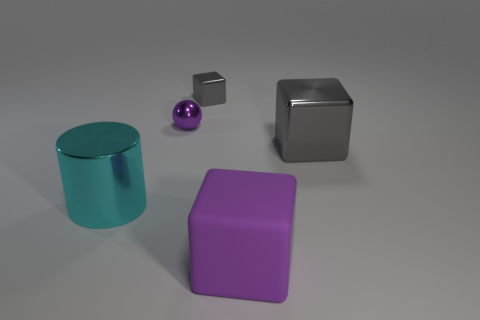Subtract all big cubes. How many cubes are left? 1 Subtract all purple blocks. How many blocks are left? 2 Subtract 2 cubes. How many cubes are left? 1 Add 2 big matte cubes. How many objects exist? 7 Subtract all balls. How many objects are left? 4 Subtract all gray balls. Subtract all purple blocks. How many balls are left? 1 Subtract all cyan blocks. How many brown cylinders are left? 0 Subtract all small cyan rubber spheres. Subtract all small purple things. How many objects are left? 4 Add 5 gray metallic objects. How many gray metallic objects are left? 7 Add 5 metallic things. How many metallic things exist? 9 